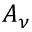Convert formula to latex. <formula><loc_0><loc_0><loc_500><loc_500>A _ { \nu }</formula> 